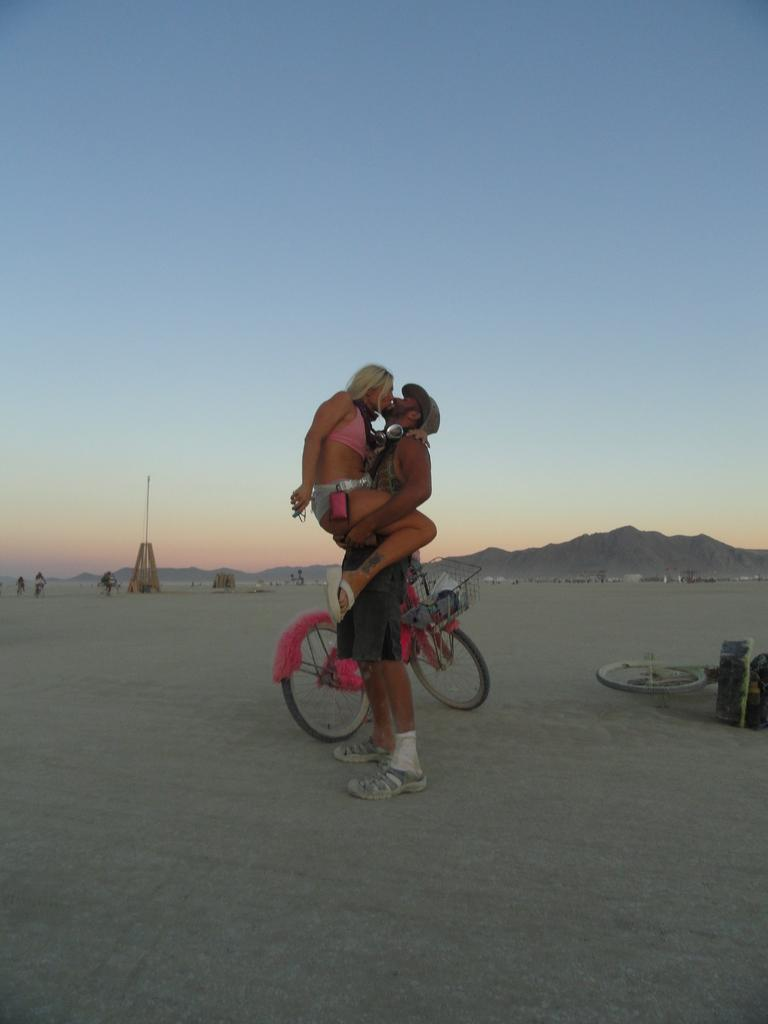What is happening in the image involving a man and a woman? The man is carrying a woman, and they are kissing each other. What can be seen in the image related to transportation? There are two bicycles in the image. What else is present in the image besides the man, woman, and bicycles? There are some objects in the image. What is visible at the top of the image? The sky is visible at the top of the image. How many trucks are visible in the image? There are no trucks present in the image. What is the man attempting to do in the image? The man is not attempting to do anything specific in the image; he is carrying a woman and kissing her. 